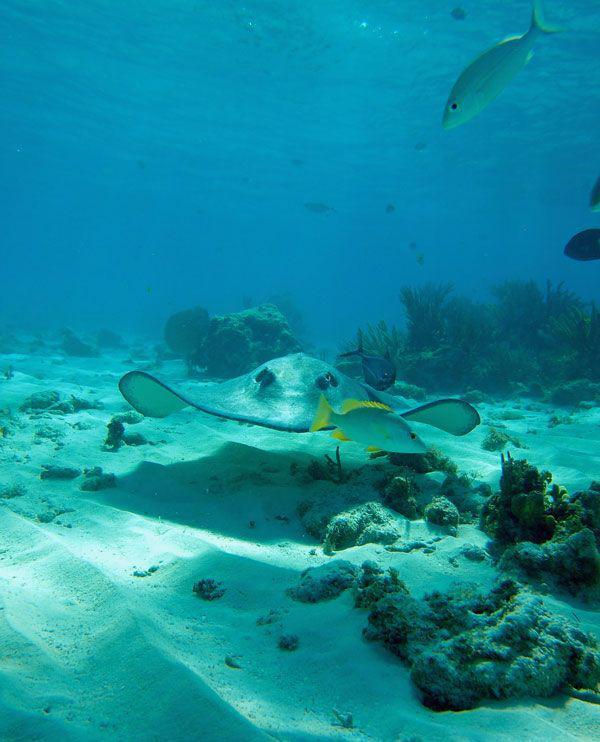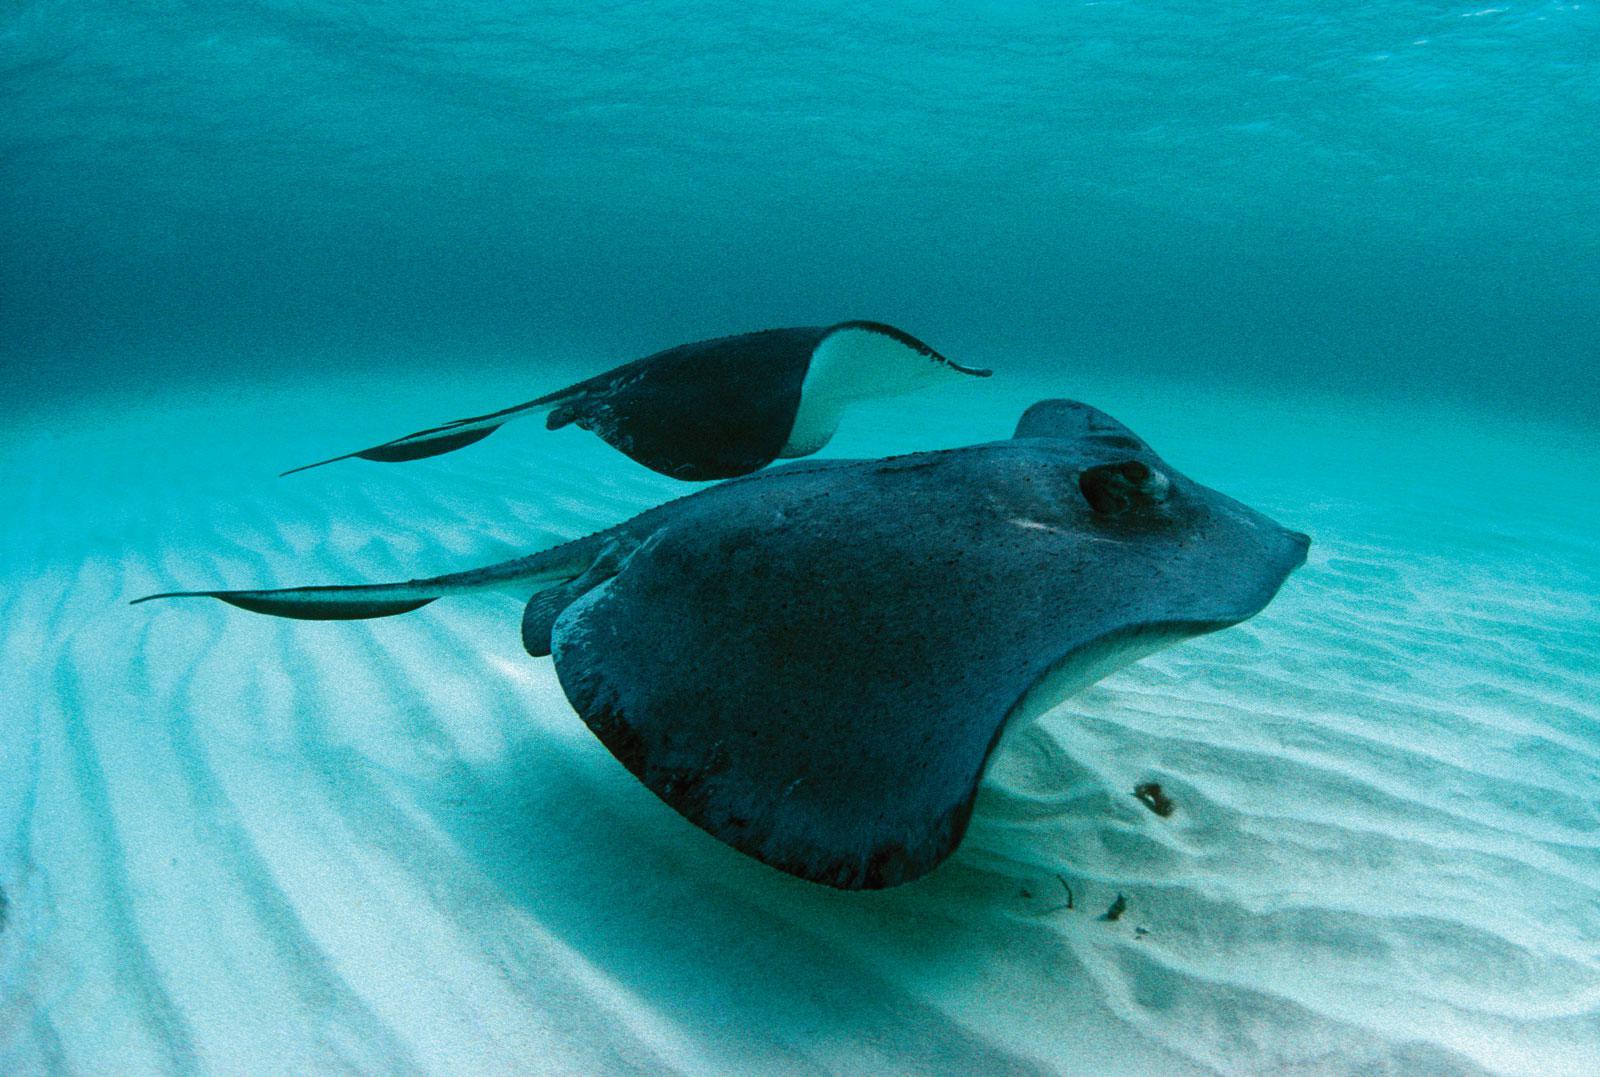The first image is the image on the left, the second image is the image on the right. Considering the images on both sides, is "There are at least two stingrays visible in the right image." valid? Answer yes or no. Yes. 